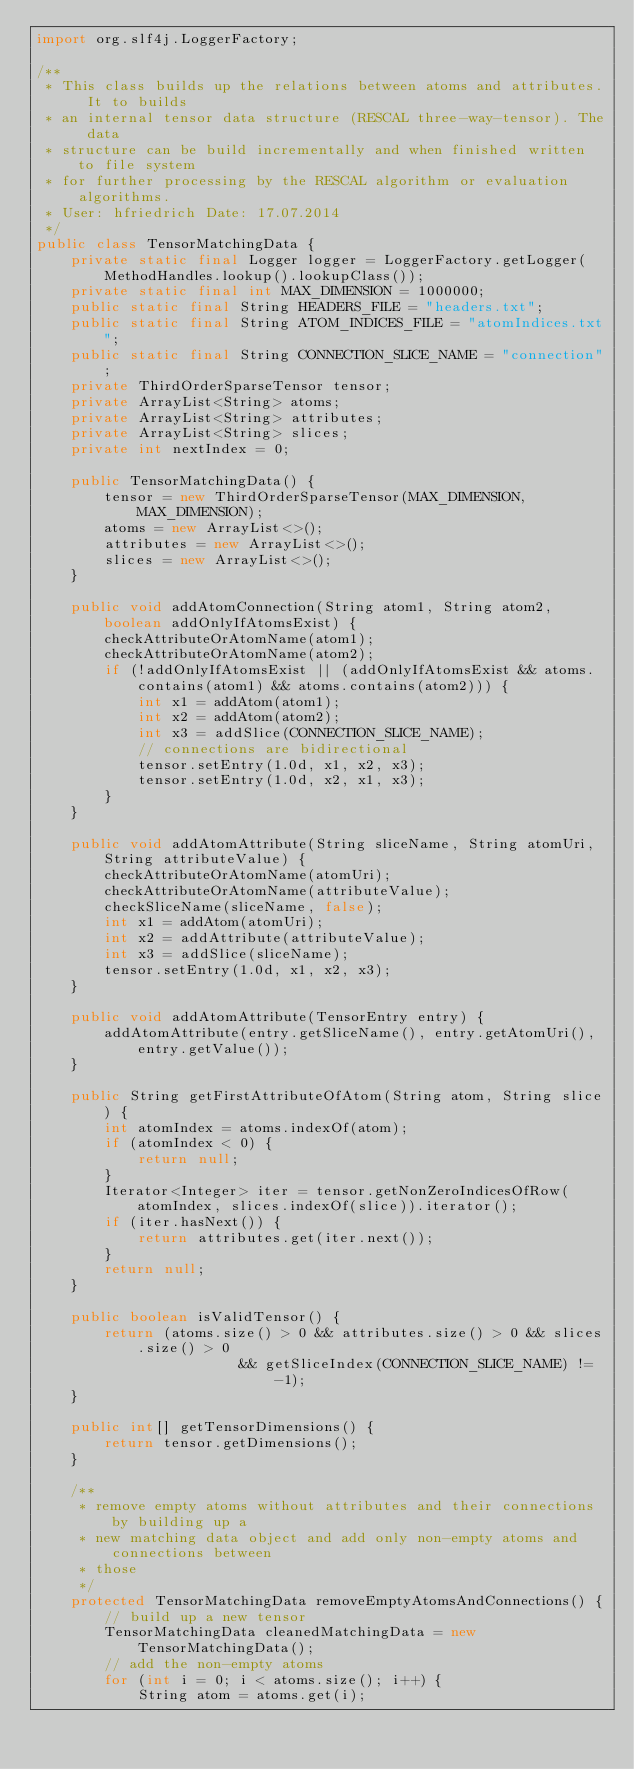<code> <loc_0><loc_0><loc_500><loc_500><_Java_>import org.slf4j.LoggerFactory;

/**
 * This class builds up the relations between atoms and attributes. It to builds
 * an internal tensor data structure (RESCAL three-way-tensor). The data
 * structure can be build incrementally and when finished written to file system
 * for further processing by the RESCAL algorithm or evaluation algorithms.
 * User: hfriedrich Date: 17.07.2014
 */
public class TensorMatchingData {
    private static final Logger logger = LoggerFactory.getLogger(MethodHandles.lookup().lookupClass());
    private static final int MAX_DIMENSION = 1000000;
    public static final String HEADERS_FILE = "headers.txt";
    public static final String ATOM_INDICES_FILE = "atomIndices.txt";
    public static final String CONNECTION_SLICE_NAME = "connection";
    private ThirdOrderSparseTensor tensor;
    private ArrayList<String> atoms;
    private ArrayList<String> attributes;
    private ArrayList<String> slices;
    private int nextIndex = 0;

    public TensorMatchingData() {
        tensor = new ThirdOrderSparseTensor(MAX_DIMENSION, MAX_DIMENSION);
        atoms = new ArrayList<>();
        attributes = new ArrayList<>();
        slices = new ArrayList<>();
    }

    public void addAtomConnection(String atom1, String atom2, boolean addOnlyIfAtomsExist) {
        checkAttributeOrAtomName(atom1);
        checkAttributeOrAtomName(atom2);
        if (!addOnlyIfAtomsExist || (addOnlyIfAtomsExist && atoms.contains(atom1) && atoms.contains(atom2))) {
            int x1 = addAtom(atom1);
            int x2 = addAtom(atom2);
            int x3 = addSlice(CONNECTION_SLICE_NAME);
            // connections are bidirectional
            tensor.setEntry(1.0d, x1, x2, x3);
            tensor.setEntry(1.0d, x2, x1, x3);
        }
    }

    public void addAtomAttribute(String sliceName, String atomUri, String attributeValue) {
        checkAttributeOrAtomName(atomUri);
        checkAttributeOrAtomName(attributeValue);
        checkSliceName(sliceName, false);
        int x1 = addAtom(atomUri);
        int x2 = addAttribute(attributeValue);
        int x3 = addSlice(sliceName);
        tensor.setEntry(1.0d, x1, x2, x3);
    }

    public void addAtomAttribute(TensorEntry entry) {
        addAtomAttribute(entry.getSliceName(), entry.getAtomUri(), entry.getValue());
    }

    public String getFirstAttributeOfAtom(String atom, String slice) {
        int atomIndex = atoms.indexOf(atom);
        if (atomIndex < 0) {
            return null;
        }
        Iterator<Integer> iter = tensor.getNonZeroIndicesOfRow(atomIndex, slices.indexOf(slice)).iterator();
        if (iter.hasNext()) {
            return attributes.get(iter.next());
        }
        return null;
    }

    public boolean isValidTensor() {
        return (atoms.size() > 0 && attributes.size() > 0 && slices.size() > 0
                        && getSliceIndex(CONNECTION_SLICE_NAME) != -1);
    }

    public int[] getTensorDimensions() {
        return tensor.getDimensions();
    }

    /**
     * remove empty atoms without attributes and their connections by building up a
     * new matching data object and add only non-empty atoms and connections between
     * those
     */
    protected TensorMatchingData removeEmptyAtomsAndConnections() {
        // build up a new tensor
        TensorMatchingData cleanedMatchingData = new TensorMatchingData();
        // add the non-empty atoms
        for (int i = 0; i < atoms.size(); i++) {
            String atom = atoms.get(i);</code> 